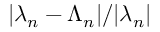Convert formula to latex. <formula><loc_0><loc_0><loc_500><loc_500>| \lambda _ { n } - \Lambda _ { n } | / | \lambda _ { n } |</formula> 